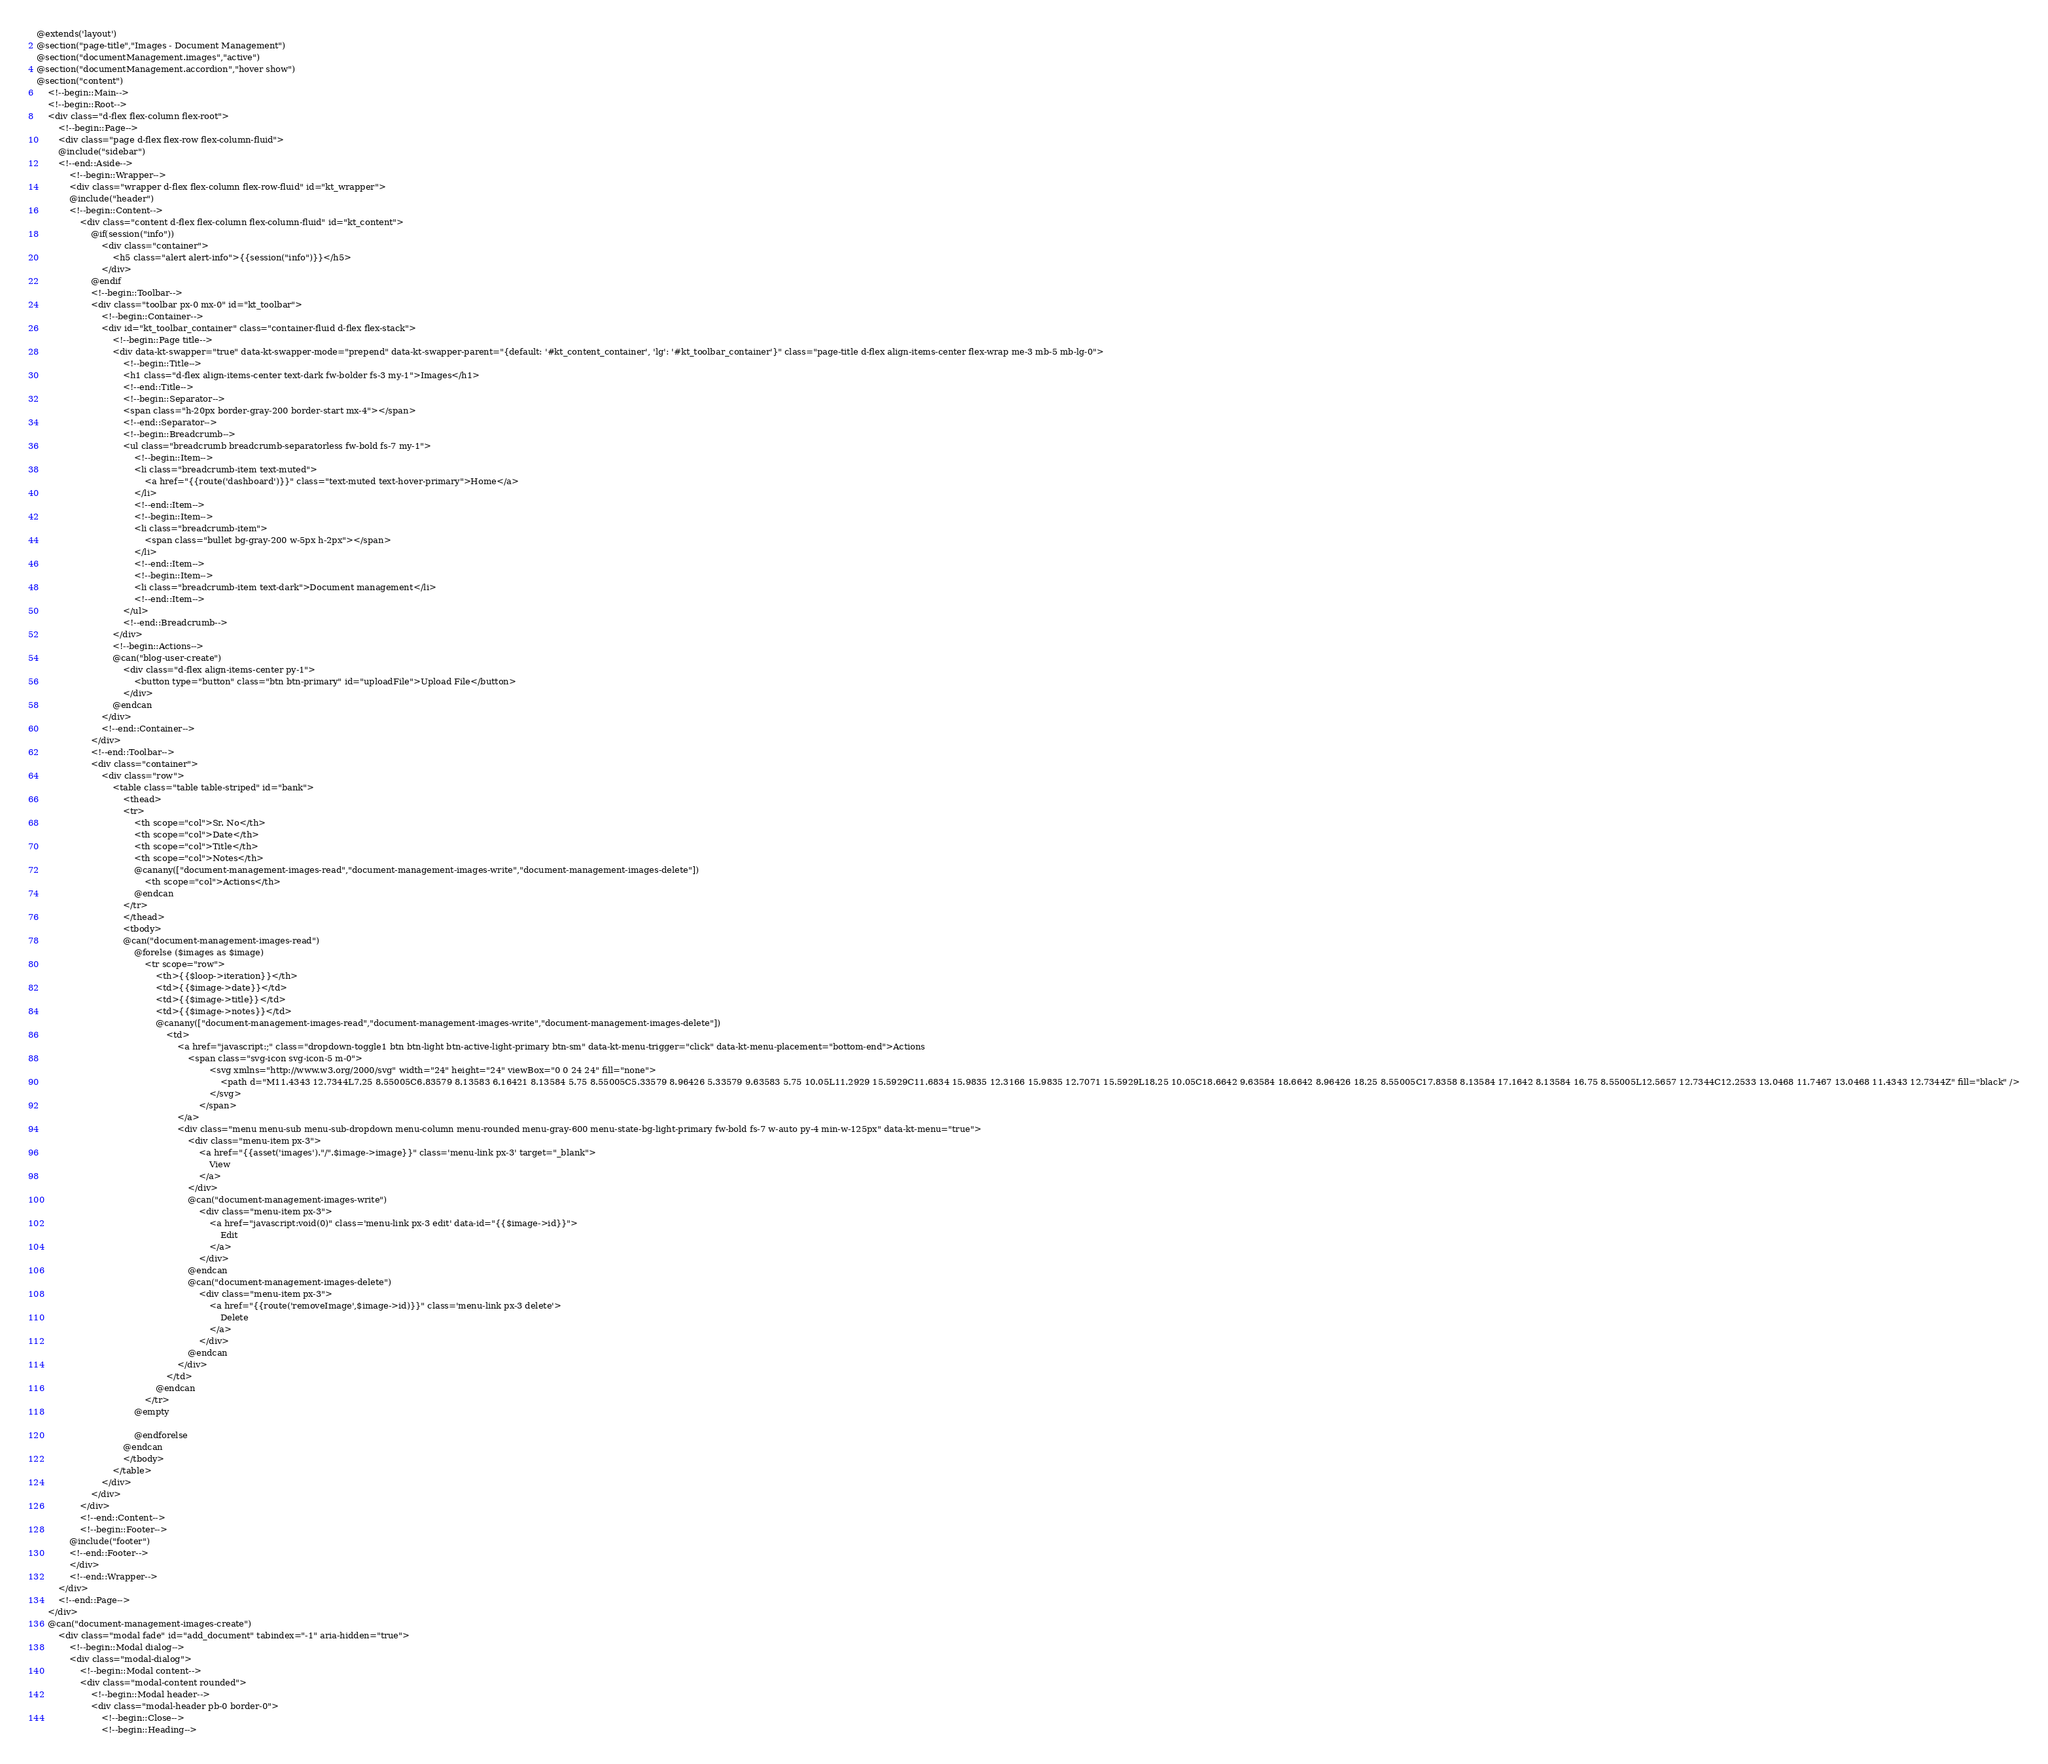Convert code to text. <code><loc_0><loc_0><loc_500><loc_500><_PHP_>@extends('layout')
@section("page-title","Images - Document Management")
@section("documentManagement.images","active")
@section("documentManagement.accordion","hover show")
@section("content")
    <!--begin::Main-->
    <!--begin::Root-->
    <div class="d-flex flex-column flex-root">
        <!--begin::Page-->
        <div class="page d-flex flex-row flex-column-fluid">
        @include("sidebar")
        <!--end::Aside-->
            <!--begin::Wrapper-->
            <div class="wrapper d-flex flex-column flex-row-fluid" id="kt_wrapper">
            @include("header")
            <!--begin::Content-->
                <div class="content d-flex flex-column flex-column-fluid" id="kt_content">
                    @if(session("info"))
                        <div class="container">
                            <h5 class="alert alert-info">{{session("info")}}</h5>
                        </div>
                    @endif
                    <!--begin::Toolbar-->
                    <div class="toolbar px-0 mx-0" id="kt_toolbar">
                        <!--begin::Container-->
                        <div id="kt_toolbar_container" class="container-fluid d-flex flex-stack">
                            <!--begin::Page title-->
                            <div data-kt-swapper="true" data-kt-swapper-mode="prepend" data-kt-swapper-parent="{default: '#kt_content_container', 'lg': '#kt_toolbar_container'}" class="page-title d-flex align-items-center flex-wrap me-3 mb-5 mb-lg-0">
                                <!--begin::Title-->
                                <h1 class="d-flex align-items-center text-dark fw-bolder fs-3 my-1">Images</h1>
                                <!--end::Title-->
                                <!--begin::Separator-->
                                <span class="h-20px border-gray-200 border-start mx-4"></span>
                                <!--end::Separator-->
                                <!--begin::Breadcrumb-->
                                <ul class="breadcrumb breadcrumb-separatorless fw-bold fs-7 my-1">
                                    <!--begin::Item-->
                                    <li class="breadcrumb-item text-muted">
                                        <a href="{{route('dashboard')}}" class="text-muted text-hover-primary">Home</a>
                                    </li>
                                    <!--end::Item-->
                                    <!--begin::Item-->
                                    <li class="breadcrumb-item">
                                        <span class="bullet bg-gray-200 w-5px h-2px"></span>
                                    </li>
                                    <!--end::Item-->
                                    <!--begin::Item-->
                                    <li class="breadcrumb-item text-dark">Document management</li>
                                    <!--end::Item-->
                                </ul>
                                <!--end::Breadcrumb-->
                            </div>
                            <!--begin::Actions-->
                            @can("blog-user-create")
                                <div class="d-flex align-items-center py-1">
                                    <button type="button" class="btn btn-primary" id="uploadFile">Upload File</button>
                                </div>
                            @endcan
                        </div>
                        <!--end::Container-->
                    </div>
                    <!--end::Toolbar-->
                    <div class="container">
                        <div class="row">
                            <table class="table table-striped" id="bank">
                                <thead>
                                <tr>
                                    <th scope="col">Sr. No</th>
                                    <th scope="col">Date</th>
                                    <th scope="col">Title</th>
                                    <th scope="col">Notes</th>
                                    @canany(["document-management-images-read","document-management-images-write","document-management-images-delete"])
                                        <th scope="col">Actions</th>
                                    @endcan
                                </tr>
                                </thead>
                                <tbody>
                                @can("document-management-images-read")
                                    @forelse ($images as $image)
                                        <tr scope="row">
                                            <th>{{$loop->iteration}}</th>
                                            <td>{{$image->date}}</td>
                                            <td>{{$image->title}}</td>
                                            <td>{{$image->notes}}</td>
                                            @canany(["document-management-images-read","document-management-images-write","document-management-images-delete"])
                                                <td>
                                                    <a href="javascript:;" class="dropdown-toggle1 btn btn-light btn-active-light-primary btn-sm" data-kt-menu-trigger="click" data-kt-menu-placement="bottom-end">Actions
                                                        <span class="svg-icon svg-icon-5 m-0">
                                                                <svg xmlns="http://www.w3.org/2000/svg" width="24" height="24" viewBox="0 0 24 24" fill="none">
                                                                    <path d="M11.4343 12.7344L7.25 8.55005C6.83579 8.13583 6.16421 8.13584 5.75 8.55005C5.33579 8.96426 5.33579 9.63583 5.75 10.05L11.2929 15.5929C11.6834 15.9835 12.3166 15.9835 12.7071 15.5929L18.25 10.05C18.6642 9.63584 18.6642 8.96426 18.25 8.55005C17.8358 8.13584 17.1642 8.13584 16.75 8.55005L12.5657 12.7344C12.2533 13.0468 11.7467 13.0468 11.4343 12.7344Z" fill="black" />
                                                                </svg>
                                                            </span>
                                                    </a>
                                                    <div class="menu menu-sub menu-sub-dropdown menu-column menu-rounded menu-gray-600 menu-state-bg-light-primary fw-bold fs-7 w-auto py-4 min-w-125px" data-kt-menu="true">
                                                        <div class="menu-item px-3">
                                                            <a href="{{asset('images')."/".$image->image}}" class='menu-link px-3' target="_blank">
                                                                View
                                                            </a>
                                                        </div>
                                                        @can("document-management-images-write")
                                                            <div class="menu-item px-3">
                                                                <a href="javascript:void(0)" class='menu-link px-3 edit' data-id="{{$image->id}}">
                                                                    Edit
                                                                </a>
                                                            </div>
                                                        @endcan
                                                        @can("document-management-images-delete")
                                                            <div class="menu-item px-3">
                                                                <a href="{{route('removeImage',$image->id)}}" class='menu-link px-3 delete'>
                                                                    Delete
                                                                </a>
                                                            </div>
                                                        @endcan
                                                    </div>
                                                </td>
                                            @endcan
                                        </tr>
                                    @empty

                                    @endforelse
                                @endcan
                                </tbody>
                            </table>
                        </div>
                    </div>
                </div>
                <!--end::Content-->
                <!--begin::Footer-->
            @include("footer")
            <!--end::Footer-->
            </div>
            <!--end::Wrapper-->
        </div>
        <!--end::Page-->
    </div>
    @can("document-management-images-create")
        <div class="modal fade" id="add_document" tabindex="-1" aria-hidden="true">
            <!--begin::Modal dialog-->
            <div class="modal-dialog">
                <!--begin::Modal content-->
                <div class="modal-content rounded">
                    <!--begin::Modal header-->
                    <div class="modal-header pb-0 border-0">
                        <!--begin::Close-->
                        <!--begin::Heading--></code> 